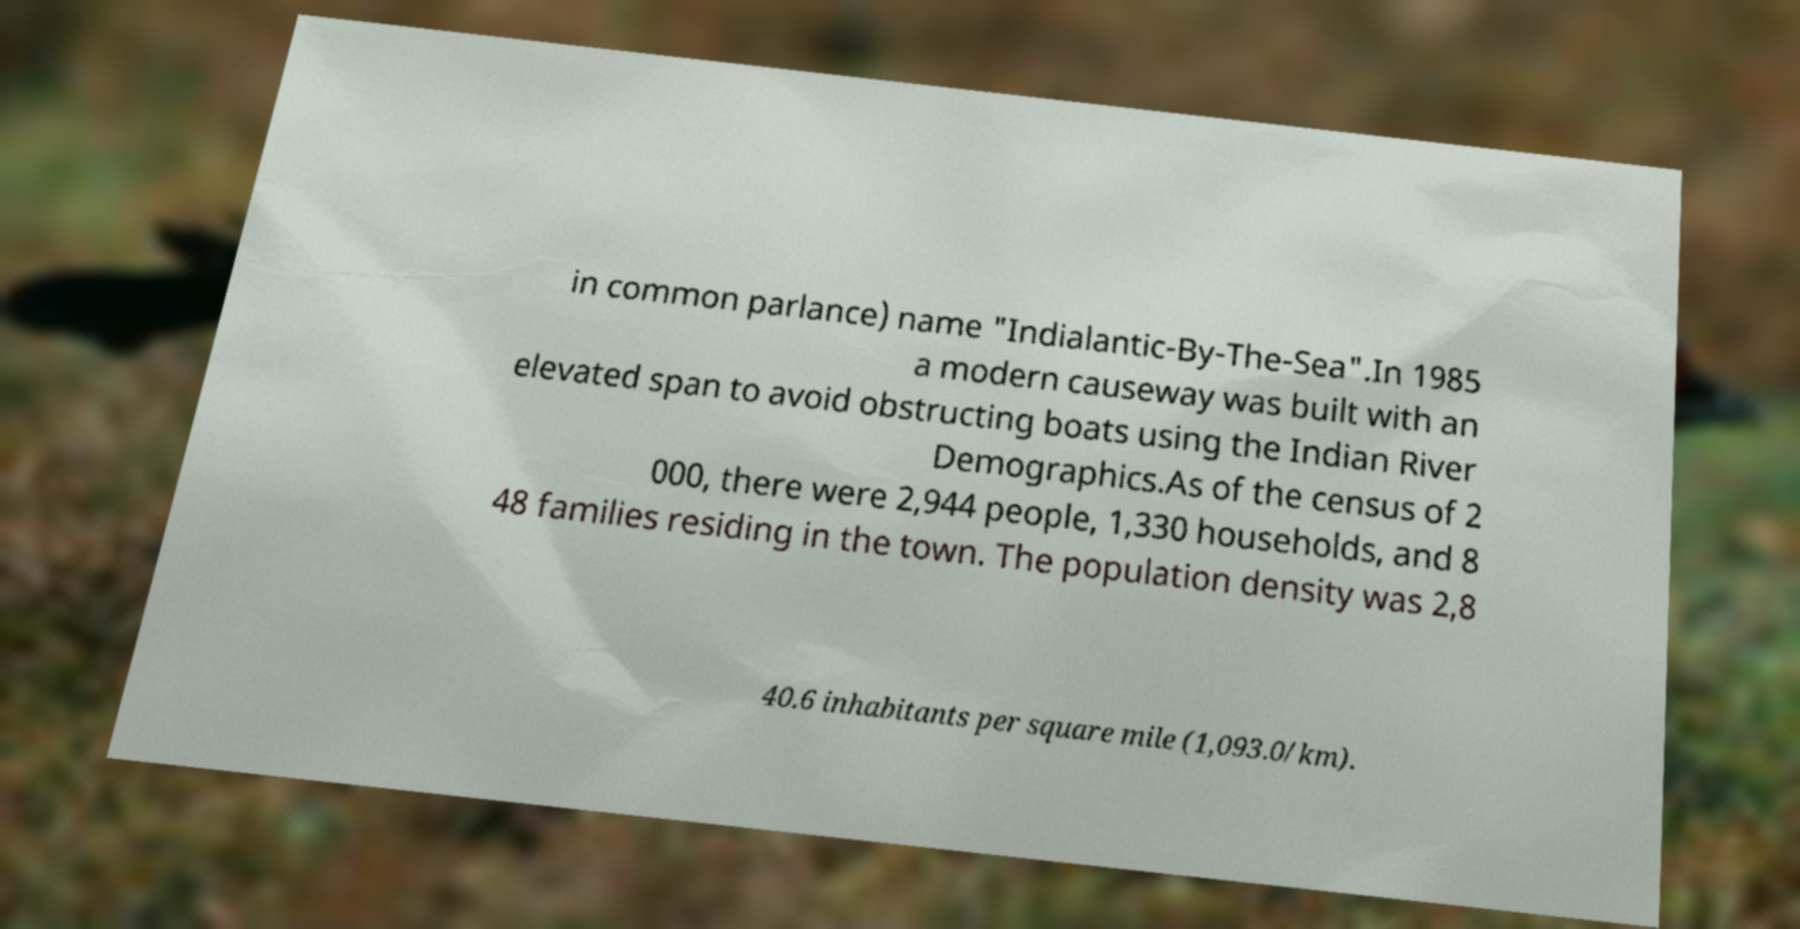Could you assist in decoding the text presented in this image and type it out clearly? in common parlance) name "Indialantic-By-The-Sea".In 1985 a modern causeway was built with an elevated span to avoid obstructing boats using the Indian River Demographics.As of the census of 2 000, there were 2,944 people, 1,330 households, and 8 48 families residing in the town. The population density was 2,8 40.6 inhabitants per square mile (1,093.0/km). 